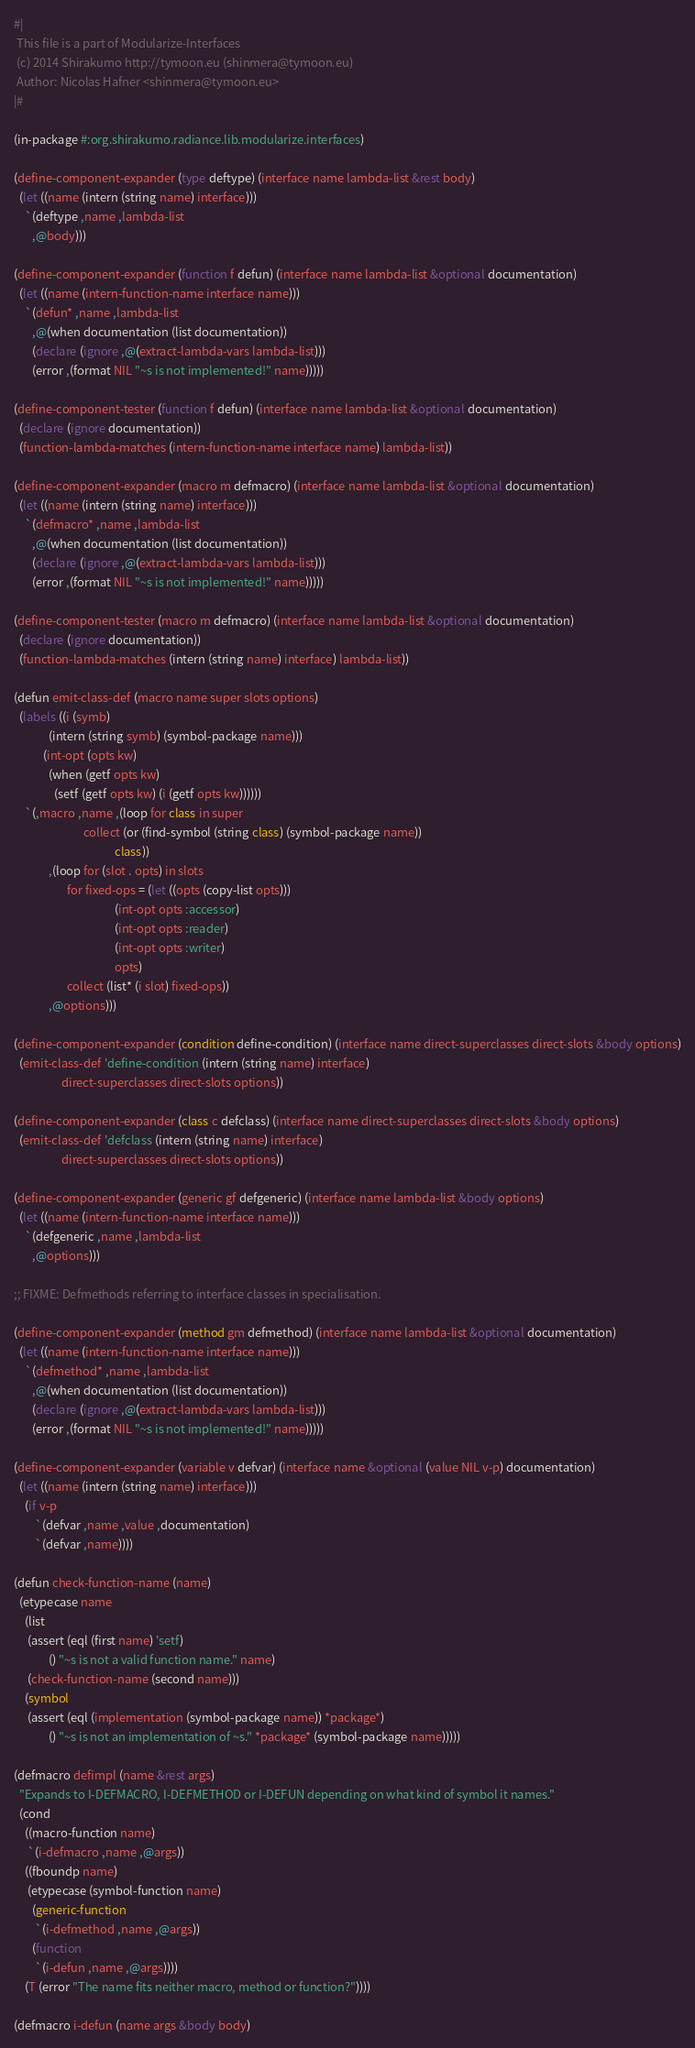Convert code to text. <code><loc_0><loc_0><loc_500><loc_500><_Lisp_>#|
 This file is a part of Modularize-Interfaces
 (c) 2014 Shirakumo http://tymoon.eu (shinmera@tymoon.eu)
 Author: Nicolas Hafner <shinmera@tymoon.eu>
|#

(in-package #:org.shirakumo.radiance.lib.modularize.interfaces)

(define-component-expander (type deftype) (interface name lambda-list &rest body)
  (let ((name (intern (string name) interface)))
    `(deftype ,name ,lambda-list
       ,@body)))

(define-component-expander (function f defun) (interface name lambda-list &optional documentation)
  (let ((name (intern-function-name interface name)))
    `(defun* ,name ,lambda-list
       ,@(when documentation (list documentation))
       (declare (ignore ,@(extract-lambda-vars lambda-list)))
       (error ,(format NIL "~s is not implemented!" name)))))

(define-component-tester (function f defun) (interface name lambda-list &optional documentation)
  (declare (ignore documentation))
  (function-lambda-matches (intern-function-name interface name) lambda-list))

(define-component-expander (macro m defmacro) (interface name lambda-list &optional documentation)
  (let ((name (intern (string name) interface)))
    `(defmacro* ,name ,lambda-list
       ,@(when documentation (list documentation))
       (declare (ignore ,@(extract-lambda-vars lambda-list)))
       (error ,(format NIL "~s is not implemented!" name)))))

(define-component-tester (macro m defmacro) (interface name lambda-list &optional documentation)
  (declare (ignore documentation))
  (function-lambda-matches (intern (string name) interface) lambda-list))

(defun emit-class-def (macro name super slots options)
  (labels ((i (symb)
             (intern (string symb) (symbol-package name)))
           (int-opt (opts kw)
             (when (getf opts kw)
               (setf (getf opts kw) (i (getf opts kw))))))
    `(,macro ,name ,(loop for class in super
                          collect (or (find-symbol (string class) (symbol-package name))
                                      class))
             ,(loop for (slot . opts) in slots
                    for fixed-ops = (let ((opts (copy-list opts)))
                                      (int-opt opts :accessor)
                                      (int-opt opts :reader)
                                      (int-opt opts :writer)
                                      opts)
                    collect (list* (i slot) fixed-ops))
             ,@options)))

(define-component-expander (condition define-condition) (interface name direct-superclasses direct-slots &body options)
  (emit-class-def 'define-condition (intern (string name) interface)
                  direct-superclasses direct-slots options))

(define-component-expander (class c defclass) (interface name direct-superclasses direct-slots &body options)
  (emit-class-def 'defclass (intern (string name) interface)
                  direct-superclasses direct-slots options))

(define-component-expander (generic gf defgeneric) (interface name lambda-list &body options)
  (let ((name (intern-function-name interface name)))
    `(defgeneric ,name ,lambda-list
       ,@options)))

;; FIXME: Defmethods referring to interface classes in specialisation.

(define-component-expander (method gm defmethod) (interface name lambda-list &optional documentation)
  (let ((name (intern-function-name interface name)))
    `(defmethod* ,name ,lambda-list
       ,@(when documentation (list documentation))
       (declare (ignore ,@(extract-lambda-vars lambda-list)))
       (error ,(format NIL "~s is not implemented!" name)))))

(define-component-expander (variable v defvar) (interface name &optional (value NIL v-p) documentation)
  (let ((name (intern (string name) interface)))
    (if v-p
        `(defvar ,name ,value ,documentation)
        `(defvar ,name))))

(defun check-function-name (name)
  (etypecase name
    (list
     (assert (eql (first name) 'setf)
             () "~s is not a valid function name." name)
     (check-function-name (second name)))
    (symbol
     (assert (eql (implementation (symbol-package name)) *package*)
             () "~s is not an implementation of ~s." *package* (symbol-package name)))))

(defmacro defimpl (name &rest args)
  "Expands to I-DEFMACRO, I-DEFMETHOD or I-DEFUN depending on what kind of symbol it names."
  (cond
    ((macro-function name)
     `(i-defmacro ,name ,@args))
    ((fboundp name)
     (etypecase (symbol-function name)
       (generic-function
        `(i-defmethod ,name ,@args))
       (function
        `(i-defun ,name ,@args))))
    (T (error "The name fits neither macro, method or function?"))))

(defmacro i-defun (name args &body body)</code> 